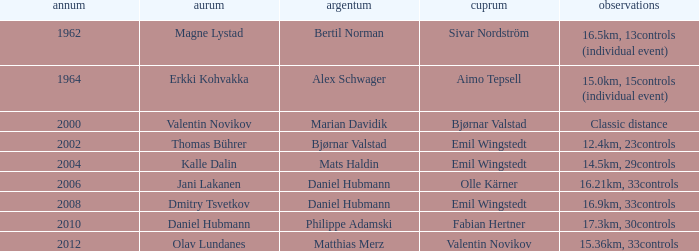WHAT IS THE YEAR WITH A BRONZE OF AIMO TEPSELL? 1964.0. 